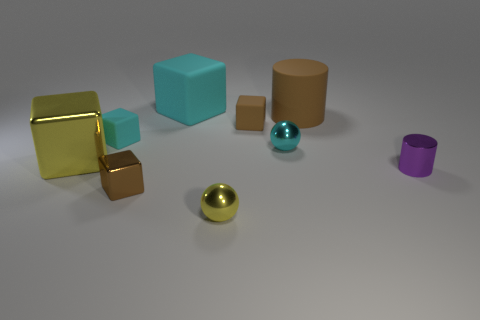Is there a big shiny cylinder of the same color as the matte cylinder?
Ensure brevity in your answer.  No. What color is the metallic block that is the same size as the yellow metal ball?
Provide a succinct answer. Brown. Is the color of the large matte cylinder the same as the cube that is right of the large cyan cube?
Offer a terse response. Yes. The big cylinder has what color?
Provide a short and direct response. Brown. There is a tiny object that is to the right of the cyan metal ball; what is it made of?
Offer a very short reply. Metal. What is the size of the other thing that is the same shape as the big brown rubber thing?
Ensure brevity in your answer.  Small. Are there fewer big cyan matte blocks right of the large brown matte thing than brown matte things?
Provide a short and direct response. Yes. Are any tiny brown cubes visible?
Your answer should be very brief. Yes. What color is the other object that is the same shape as the tiny yellow object?
Provide a succinct answer. Cyan. There is a large block that is behind the big brown thing; is its color the same as the large shiny object?
Give a very brief answer. No. 